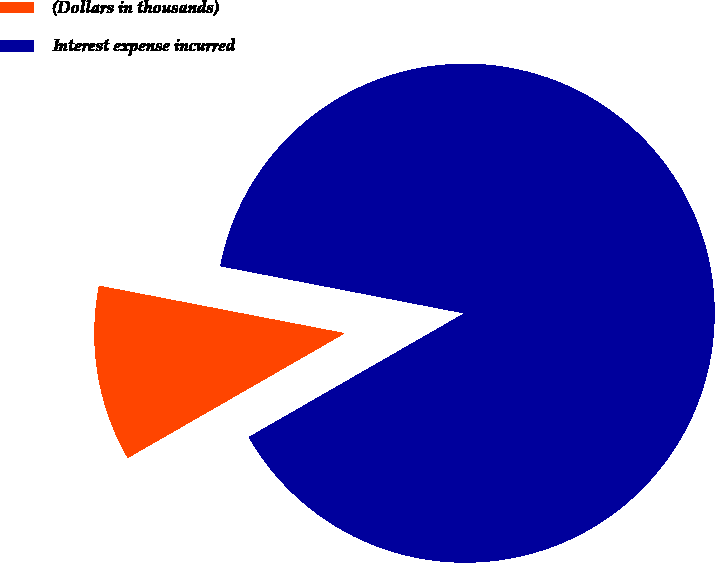Convert chart to OTSL. <chart><loc_0><loc_0><loc_500><loc_500><pie_chart><fcel>(Dollars in thousands)<fcel>Interest expense incurred<nl><fcel>11.34%<fcel>88.66%<nl></chart> 